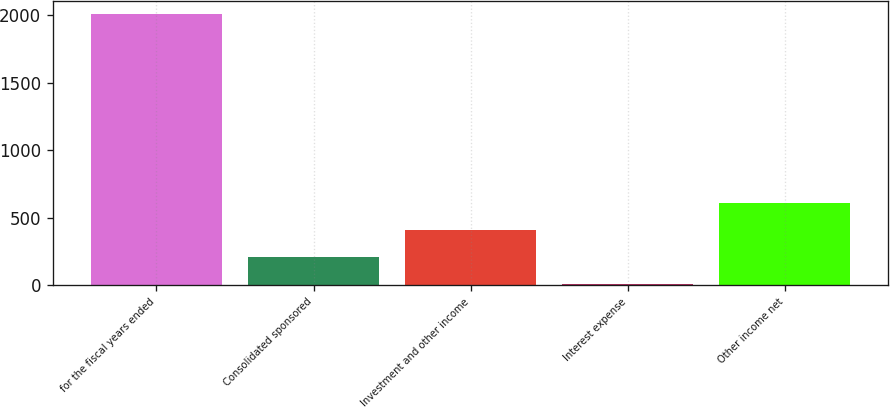<chart> <loc_0><loc_0><loc_500><loc_500><bar_chart><fcel>for the fiscal years ended<fcel>Consolidated sponsored<fcel>Investment and other income<fcel>Interest expense<fcel>Other income net<nl><fcel>2009<fcel>204.32<fcel>404.84<fcel>3.8<fcel>605.36<nl></chart> 